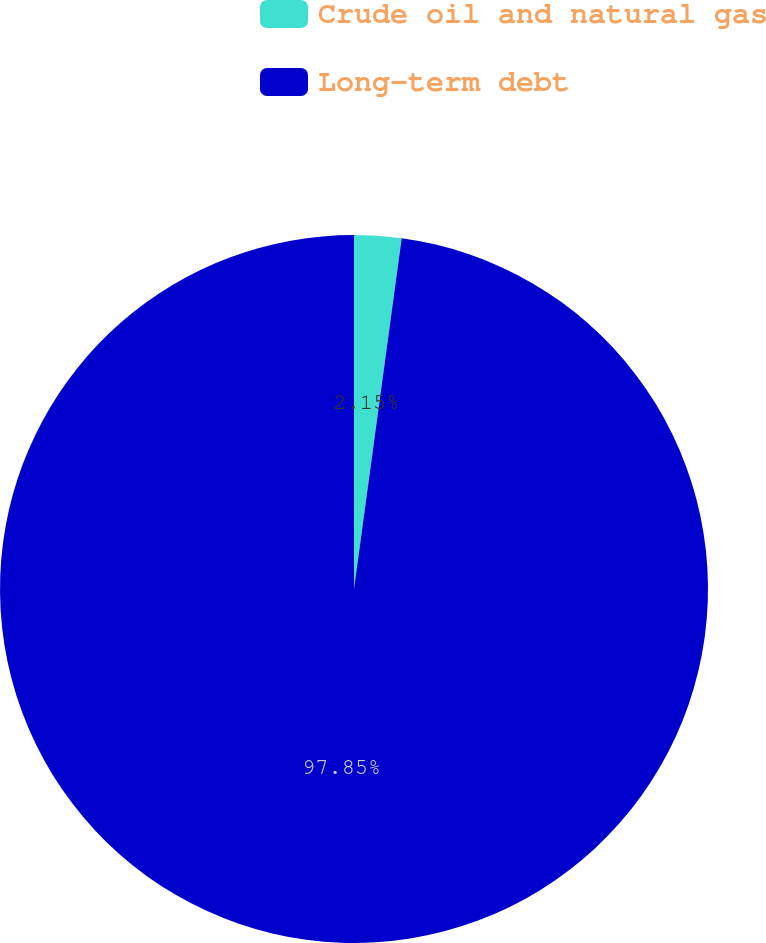<chart> <loc_0><loc_0><loc_500><loc_500><pie_chart><fcel>Crude oil and natural gas<fcel>Long-term debt<nl><fcel>2.15%<fcel>97.85%<nl></chart> 